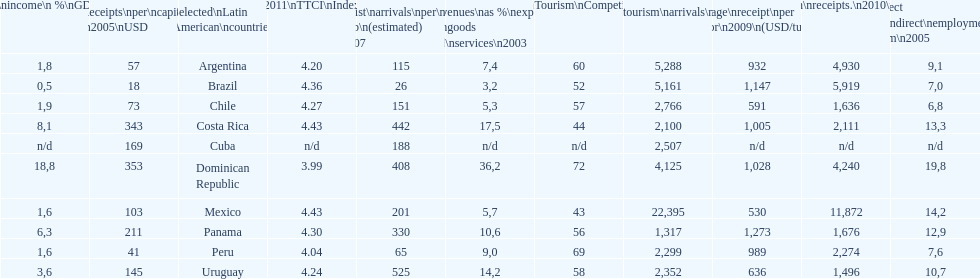How many dollars on average did brazil receive per tourist in 2009? 1,147. 